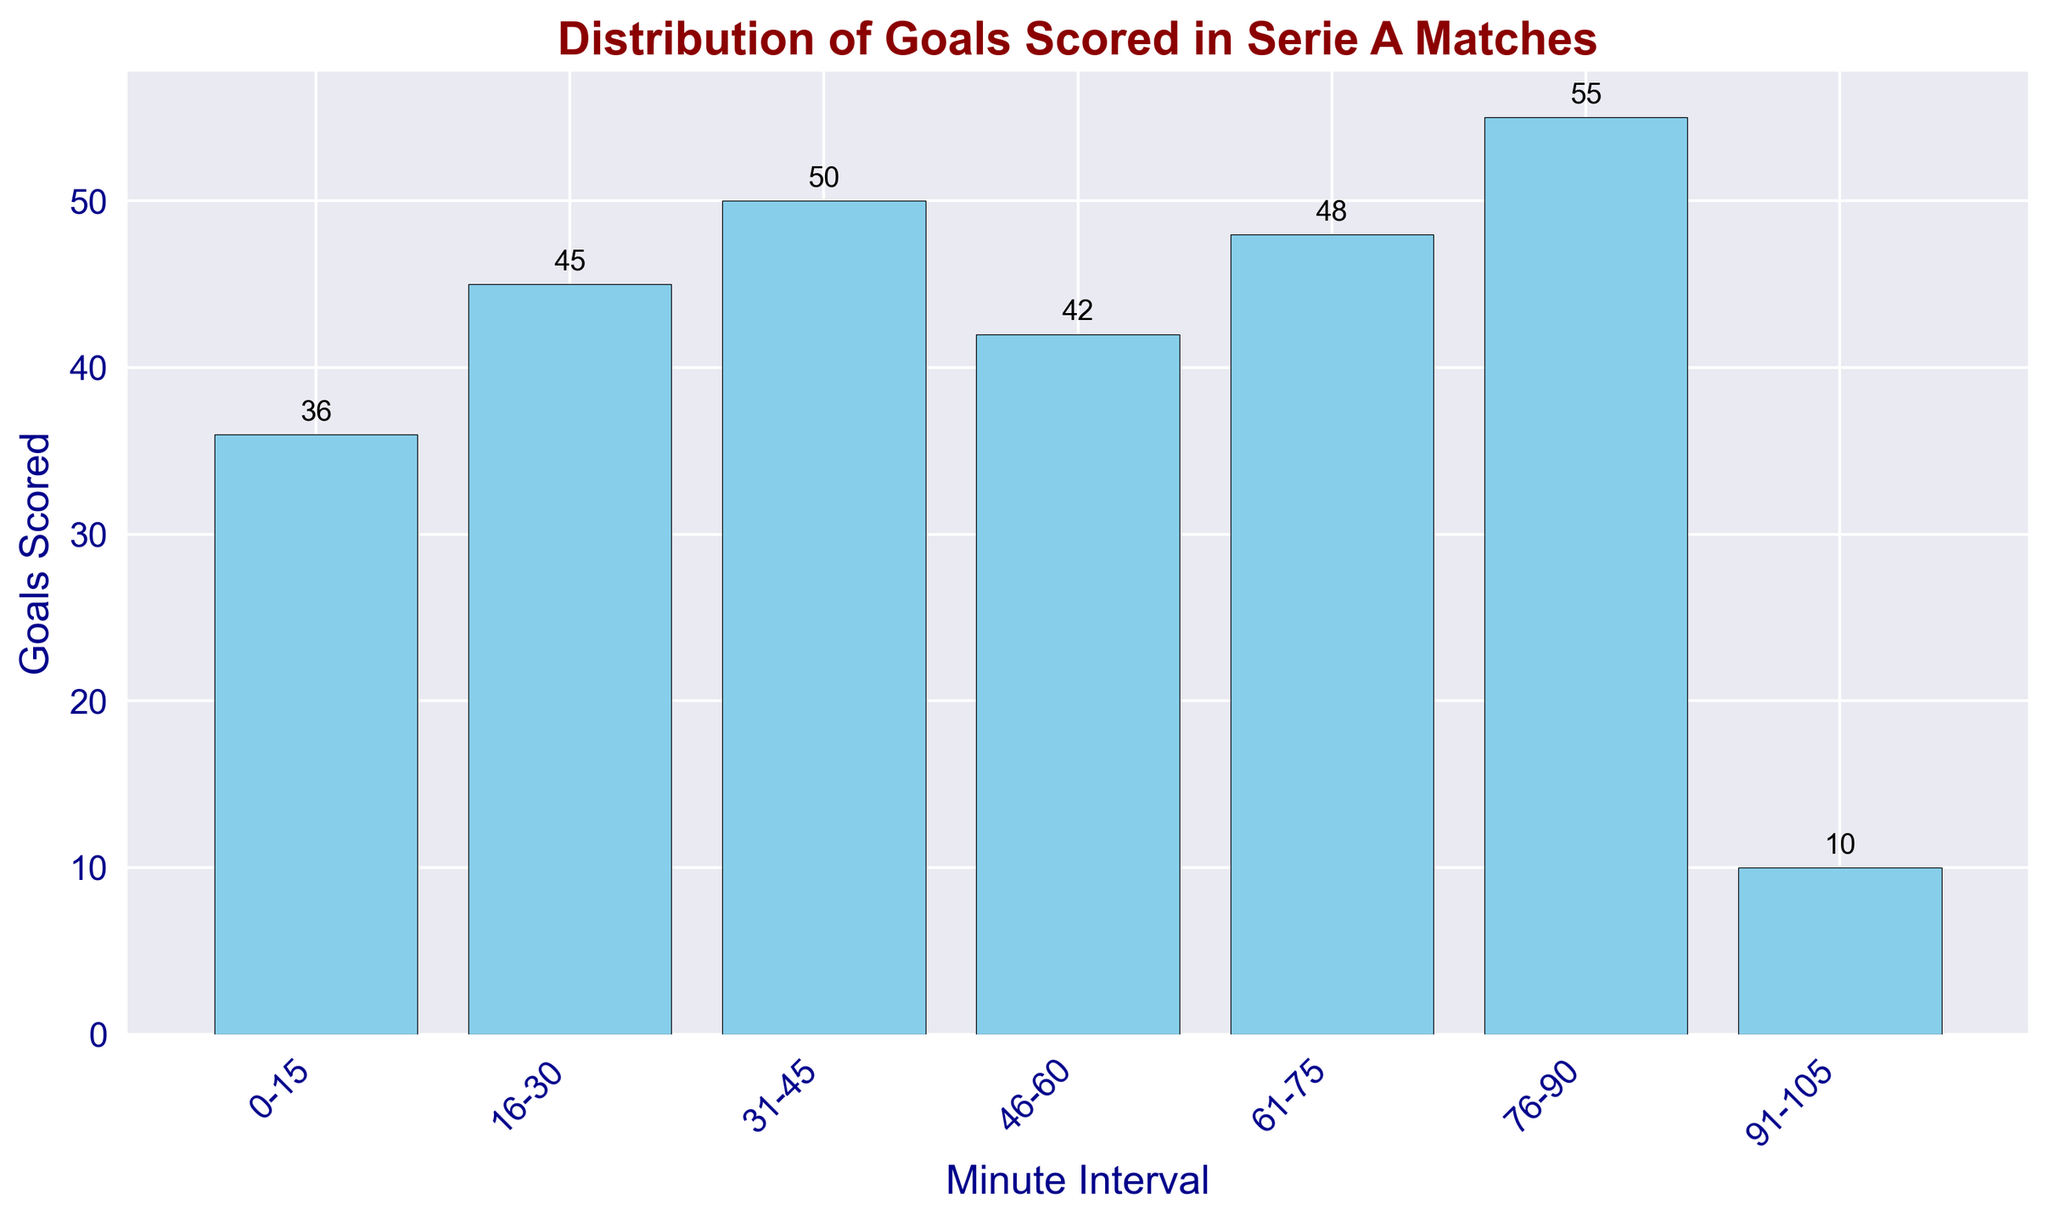What minute interval has the highest number of goals scored? The histogram shows the height of each bar representing the goals scored in each minute interval. The bar for the interval 76-90 appears highest.
Answer: 76-90 How many goals were scored in the first three minute intervals (0-15, 16-30, and 31-45)? Sum the goals in the first three intervals: 36 (0-15) + 45 (16-30) + 50 (31-45) = 131 goals.
Answer: 131 Which minute interval has more goals scored: 46-60 or 61-75? Compare the bars' heights for intervals 46-60 and 61-75. The 61-75 interval is higher with 48 goals compared to the 46-60 interval with 42 goals.
Answer: 61-75 How many more goals were scored in the last interval (91-105) compared to the first interval (0-15)? Subtract the goals in the first interval from the goals in the last interval: 10 (91-105) - 36 (0-15) = -26.
Answer: -26 What is the average number of goals scored per interval? Sum the goals scored in all intervals: 36 + 45 + 50 + 42 + 48 + 55 + 10 = 286. Divide by the number of intervals: 286 / 7 = 40.86.
Answer: 40.86 Between which two consecutive intervals is the increase in goals scored the greatest? Calculate the difference in goals between consecutive intervals: 
16-30 and 0-15: 45 - 36 = 9
31-45 and 16-30: 50 - 45 = 5
46-60 and 31-45: 42 - 50 = -8
61-75 and 46-60: 48 - 42 = 6
76-90 and 61-75: 55 - 48 = 7
91-105 and 76-90: 10 - 55 = -45
The greatest positive difference is between 0-15 and 16-30.
Answer: 0-15 and 16-30 